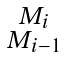<formula> <loc_0><loc_0><loc_500><loc_500>\begin{smallmatrix} M _ { i } \\ M _ { i - 1 } \end{smallmatrix}</formula> 